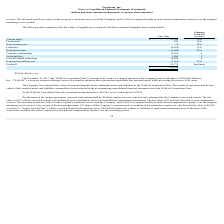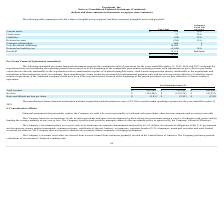According to Proofpoint's financial document, What is the amount of net cash acquired at the WebLife Acquisition Date? According to the financial document, $278 (in thousands). The relevant text states: "n transferred was $48,765, net of cash acquired of $278...." Also, Under what conditions were the deferred shares subjected to forfeiture? If employment terminates prior to the lapse of the restrictions, and their fair value is expensed as stock-based compensation expense over the remaining period. The document states: "ce. The deferred shares are subject to forfeiture if employment terminates prior to the lapse of the restrictions, and their fair value is expensed as..." Also, What is the amount of Goodwill in fair value? According to the financial document, 36,514 (in thousands). The relevant text states: "Goodwill 36,514 Indefinite..." Also, can you calculate: What is the difference in fair value between current assets and fixed assets? Based on the calculation: $534 - 23, the result is 511 (in thousands). This is based on the information: "Current assets $ 534 N/A Fixed assets 23 N/A..." The key data points involved are: 23, 534. Also, can you calculate: What is the average fair value of Core/developed technology? Based on the calculation: 16,600 / 5, the result is 3320 (in thousands). This is based on the information: "Core/developed technology 16,600 5 Core/developed technology 16,600 5..." The key data points involved are: 16,600, 5. Also, can you calculate: What is the total fair value of all tangible assets? Based on the calculation: $534 + 23, the result is 557 (in thousands). This is based on the information: "Current assets $ 534 N/A Fixed assets 23 N/A..." The key data points involved are: 23, 534. 